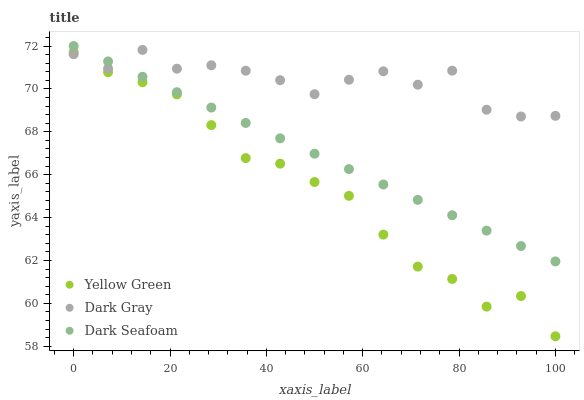Does Yellow Green have the minimum area under the curve?
Answer yes or no. Yes. Does Dark Gray have the maximum area under the curve?
Answer yes or no. Yes. Does Dark Seafoam have the minimum area under the curve?
Answer yes or no. No. Does Dark Seafoam have the maximum area under the curve?
Answer yes or no. No. Is Dark Seafoam the smoothest?
Answer yes or no. Yes. Is Dark Gray the roughest?
Answer yes or no. Yes. Is Yellow Green the smoothest?
Answer yes or no. No. Is Yellow Green the roughest?
Answer yes or no. No. Does Yellow Green have the lowest value?
Answer yes or no. Yes. Does Dark Seafoam have the lowest value?
Answer yes or no. No. Does Dark Seafoam have the highest value?
Answer yes or no. Yes. Does Yellow Green have the highest value?
Answer yes or no. No. Is Yellow Green less than Dark Seafoam?
Answer yes or no. Yes. Is Dark Seafoam greater than Yellow Green?
Answer yes or no. Yes. Does Yellow Green intersect Dark Gray?
Answer yes or no. Yes. Is Yellow Green less than Dark Gray?
Answer yes or no. No. Is Yellow Green greater than Dark Gray?
Answer yes or no. No. Does Yellow Green intersect Dark Seafoam?
Answer yes or no. No. 